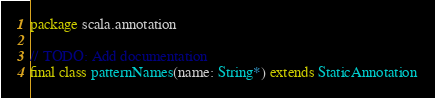Convert code to text. <code><loc_0><loc_0><loc_500><loc_500><_Scala_>package scala.annotation

// TODO: Add documentation
final class patternNames(name: String*) extends StaticAnnotation
</code> 